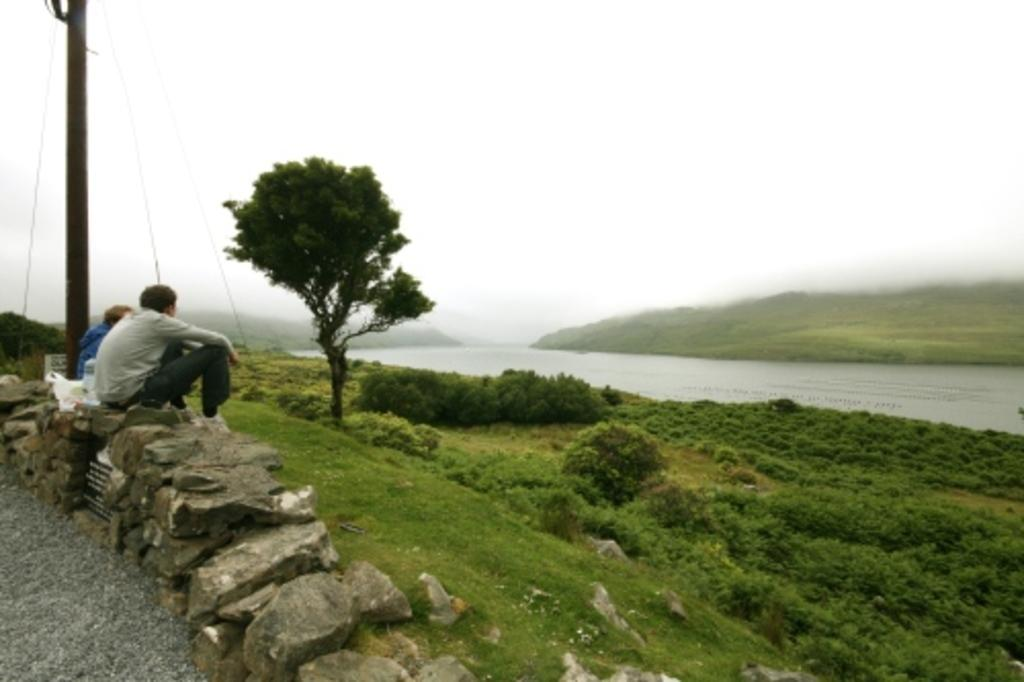What type of vegetation can be seen in the image? There is grass, plants, and a tree visible in the image. What other natural elements are present in the image? There are rocks and water visible in the image. What man-made object can be seen in the image? There is a current pole in the image. How many people are present in the image? There are two people sitting on rocks in the image. What is visible at the top of the image? The sky is visible at the top of the image. What quarter is the coast located in the image? There is no coast present in the image, and therefore no quarter can be associated with it. What level of the waterfall can be seen in the image? There is no waterfall present in the image. 